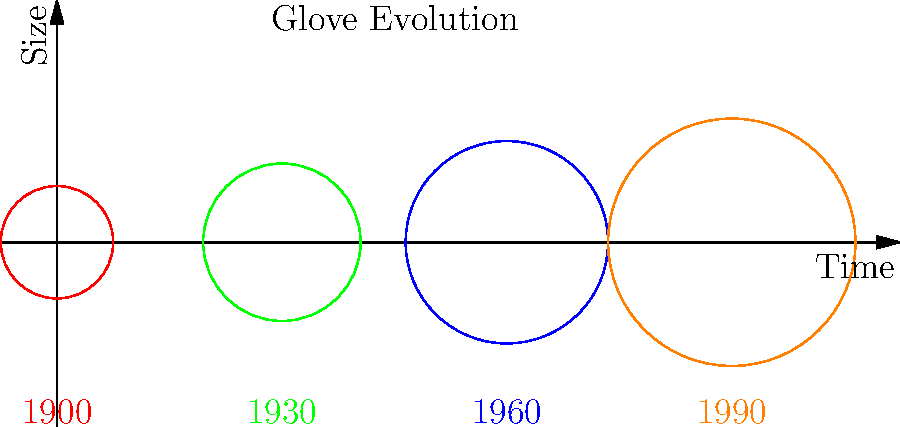Based on the graphic illustrating the evolution of baseball glove designs used by Boston players from different eras, which decade saw the most significant increase in glove size? To determine the decade with the most significant increase in glove size, we need to analyze the changes between consecutive time periods:

1. 1900 to 1930: The glove size increases from 0.5 to 0.7 units, a change of 0.2 units over 30 years.
2. 1930 to 1960: The glove size increases from 0.7 to 0.9 units, a change of 0.2 units over 30 years.
3. 1960 to 1990: The glove size increases from 0.9 to 1.1 units, a change of 0.2 units over 30 years.

The rate of change is consistent across all periods (0.2 units per 30 years). To find the change per decade, we divide 0.2 by 3:

$\frac{0.2}{3} \approx 0.067$ units per decade

Since the rate of change is constant, we can conclude that the increase in glove size was uniform across all decades from 1900 to 1990. There is no single decade that saw a more significant increase than the others.

However, it's worth noting that the relative increase was larger in the earlier decades. For example, the change from 0.5 to 0.567 (1900-1910) represents a 13.4% increase, while the change from 1.033 to 1.1 (1980-1990) represents only a 6.5% increase.
Answer: Uniform increase across all decades 